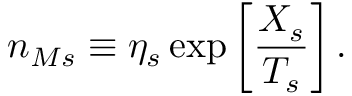Convert formula to latex. <formula><loc_0><loc_0><loc_500><loc_500>n _ { M s } \equiv \eta _ { s } \exp \left [ \frac { X _ { s } } { T _ { s } } \right ] .</formula> 